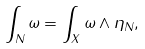Convert formula to latex. <formula><loc_0><loc_0><loc_500><loc_500>\int _ { N } \omega = \int _ { X } \omega \wedge \eta _ { N } ,</formula> 